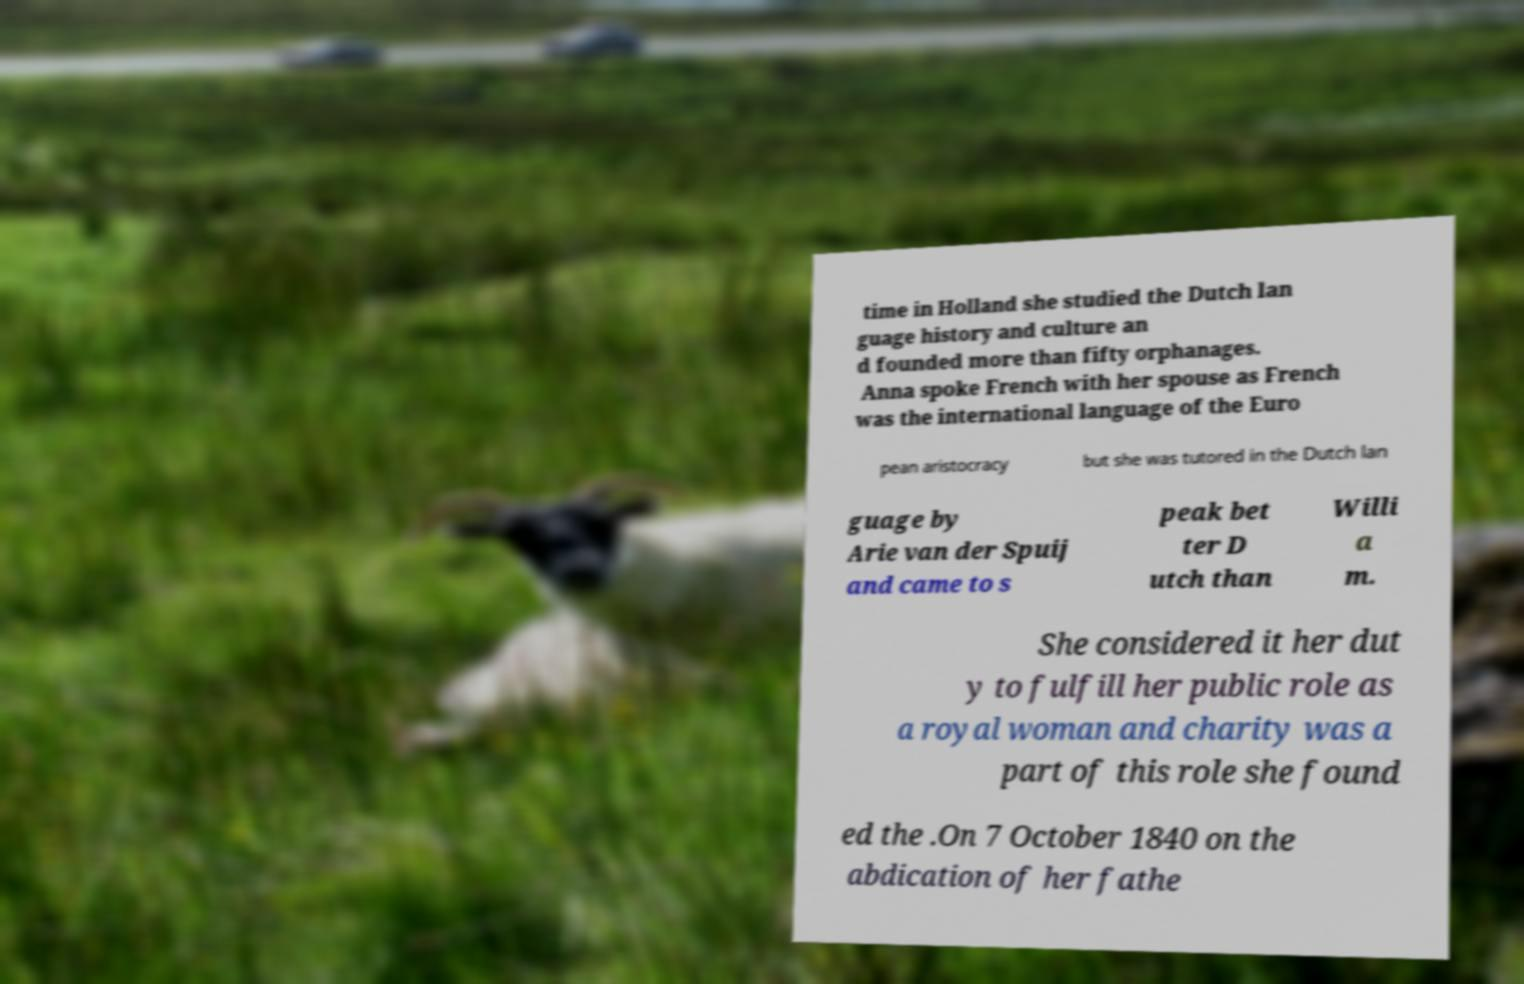Can you read and provide the text displayed in the image?This photo seems to have some interesting text. Can you extract and type it out for me? time in Holland she studied the Dutch lan guage history and culture an d founded more than fifty orphanages. Anna spoke French with her spouse as French was the international language of the Euro pean aristocracy but she was tutored in the Dutch lan guage by Arie van der Spuij and came to s peak bet ter D utch than Willi a m. She considered it her dut y to fulfill her public role as a royal woman and charity was a part of this role she found ed the .On 7 October 1840 on the abdication of her fathe 